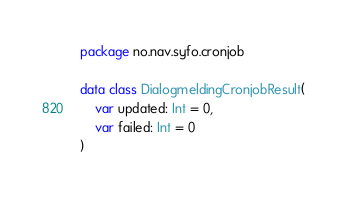Convert code to text. <code><loc_0><loc_0><loc_500><loc_500><_Kotlin_>package no.nav.syfo.cronjob

data class DialogmeldingCronjobResult(
    var updated: Int = 0,
    var failed: Int = 0
)
</code> 